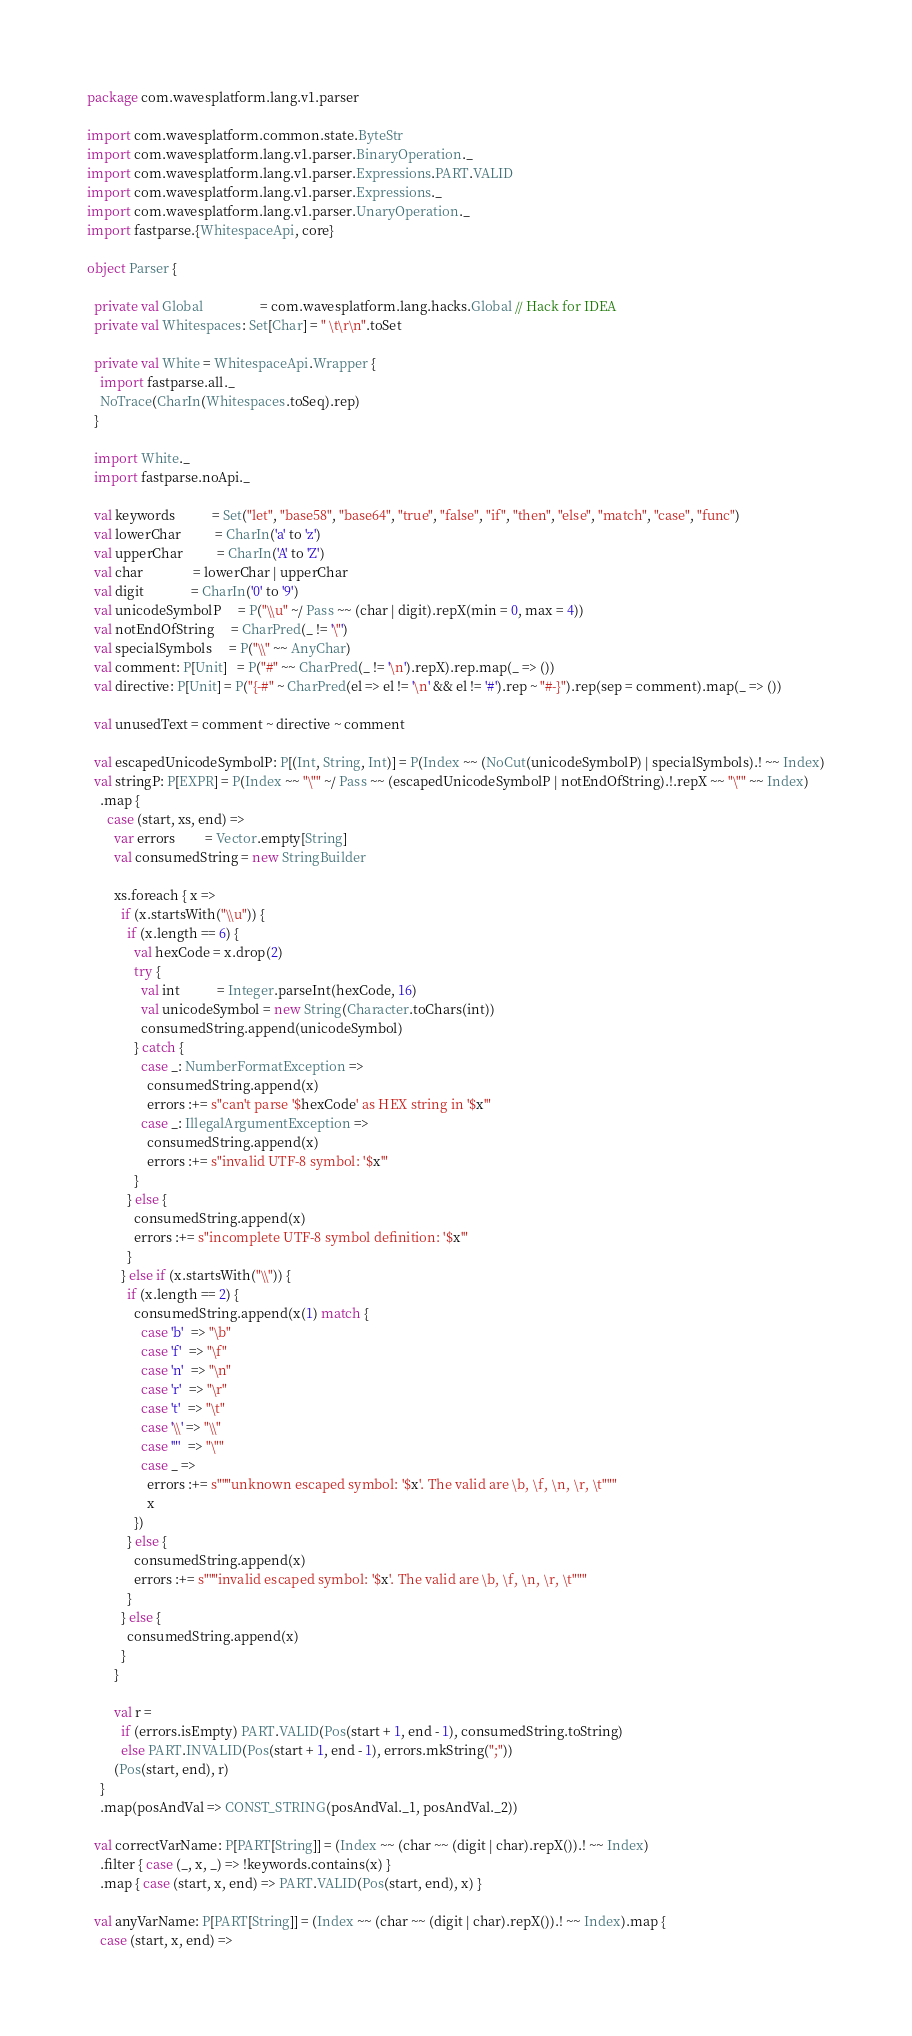Convert code to text. <code><loc_0><loc_0><loc_500><loc_500><_Scala_>package com.wavesplatform.lang.v1.parser

import com.wavesplatform.common.state.ByteStr
import com.wavesplatform.lang.v1.parser.BinaryOperation._
import com.wavesplatform.lang.v1.parser.Expressions.PART.VALID
import com.wavesplatform.lang.v1.parser.Expressions._
import com.wavesplatform.lang.v1.parser.UnaryOperation._
import fastparse.{WhitespaceApi, core}

object Parser {

  private val Global                 = com.wavesplatform.lang.hacks.Global // Hack for IDEA
  private val Whitespaces: Set[Char] = " \t\r\n".toSet

  private val White = WhitespaceApi.Wrapper {
    import fastparse.all._
    NoTrace(CharIn(Whitespaces.toSeq).rep)
  }

  import White._
  import fastparse.noApi._

  val keywords           = Set("let", "base58", "base64", "true", "false", "if", "then", "else", "match", "case", "func")
  val lowerChar          = CharIn('a' to 'z')
  val upperChar          = CharIn('A' to 'Z')
  val char               = lowerChar | upperChar
  val digit              = CharIn('0' to '9')
  val unicodeSymbolP     = P("\\u" ~/ Pass ~~ (char | digit).repX(min = 0, max = 4))
  val notEndOfString     = CharPred(_ != '\"')
  val specialSymbols     = P("\\" ~~ AnyChar)
  val comment: P[Unit]   = P("#" ~~ CharPred(_ != '\n').repX).rep.map(_ => ())
  val directive: P[Unit] = P("{-#" ~ CharPred(el => el != '\n' && el != '#').rep ~ "#-}").rep(sep = comment).map(_ => ())

  val unusedText = comment ~ directive ~ comment

  val escapedUnicodeSymbolP: P[(Int, String, Int)] = P(Index ~~ (NoCut(unicodeSymbolP) | specialSymbols).! ~~ Index)
  val stringP: P[EXPR] = P(Index ~~ "\"" ~/ Pass ~~ (escapedUnicodeSymbolP | notEndOfString).!.repX ~~ "\"" ~~ Index)
    .map {
      case (start, xs, end) =>
        var errors         = Vector.empty[String]
        val consumedString = new StringBuilder

        xs.foreach { x =>
          if (x.startsWith("\\u")) {
            if (x.length == 6) {
              val hexCode = x.drop(2)
              try {
                val int           = Integer.parseInt(hexCode, 16)
                val unicodeSymbol = new String(Character.toChars(int))
                consumedString.append(unicodeSymbol)
              } catch {
                case _: NumberFormatException =>
                  consumedString.append(x)
                  errors :+= s"can't parse '$hexCode' as HEX string in '$x'"
                case _: IllegalArgumentException =>
                  consumedString.append(x)
                  errors :+= s"invalid UTF-8 symbol: '$x'"
              }
            } else {
              consumedString.append(x)
              errors :+= s"incomplete UTF-8 symbol definition: '$x'"
            }
          } else if (x.startsWith("\\")) {
            if (x.length == 2) {
              consumedString.append(x(1) match {
                case 'b'  => "\b"
                case 'f'  => "\f"
                case 'n'  => "\n"
                case 'r'  => "\r"
                case 't'  => "\t"
                case '\\' => "\\"
                case '"'  => "\""
                case _ =>
                  errors :+= s"""unknown escaped symbol: '$x'. The valid are \b, \f, \n, \r, \t"""
                  x
              })
            } else {
              consumedString.append(x)
              errors :+= s"""invalid escaped symbol: '$x'. The valid are \b, \f, \n, \r, \t"""
            }
          } else {
            consumedString.append(x)
          }
        }

        val r =
          if (errors.isEmpty) PART.VALID(Pos(start + 1, end - 1), consumedString.toString)
          else PART.INVALID(Pos(start + 1, end - 1), errors.mkString(";"))
        (Pos(start, end), r)
    }
    .map(posAndVal => CONST_STRING(posAndVal._1, posAndVal._2))

  val correctVarName: P[PART[String]] = (Index ~~ (char ~~ (digit | char).repX()).! ~~ Index)
    .filter { case (_, x, _) => !keywords.contains(x) }
    .map { case (start, x, end) => PART.VALID(Pos(start, end), x) }

  val anyVarName: P[PART[String]] = (Index ~~ (char ~~ (digit | char).repX()).! ~~ Index).map {
    case (start, x, end) =></code> 